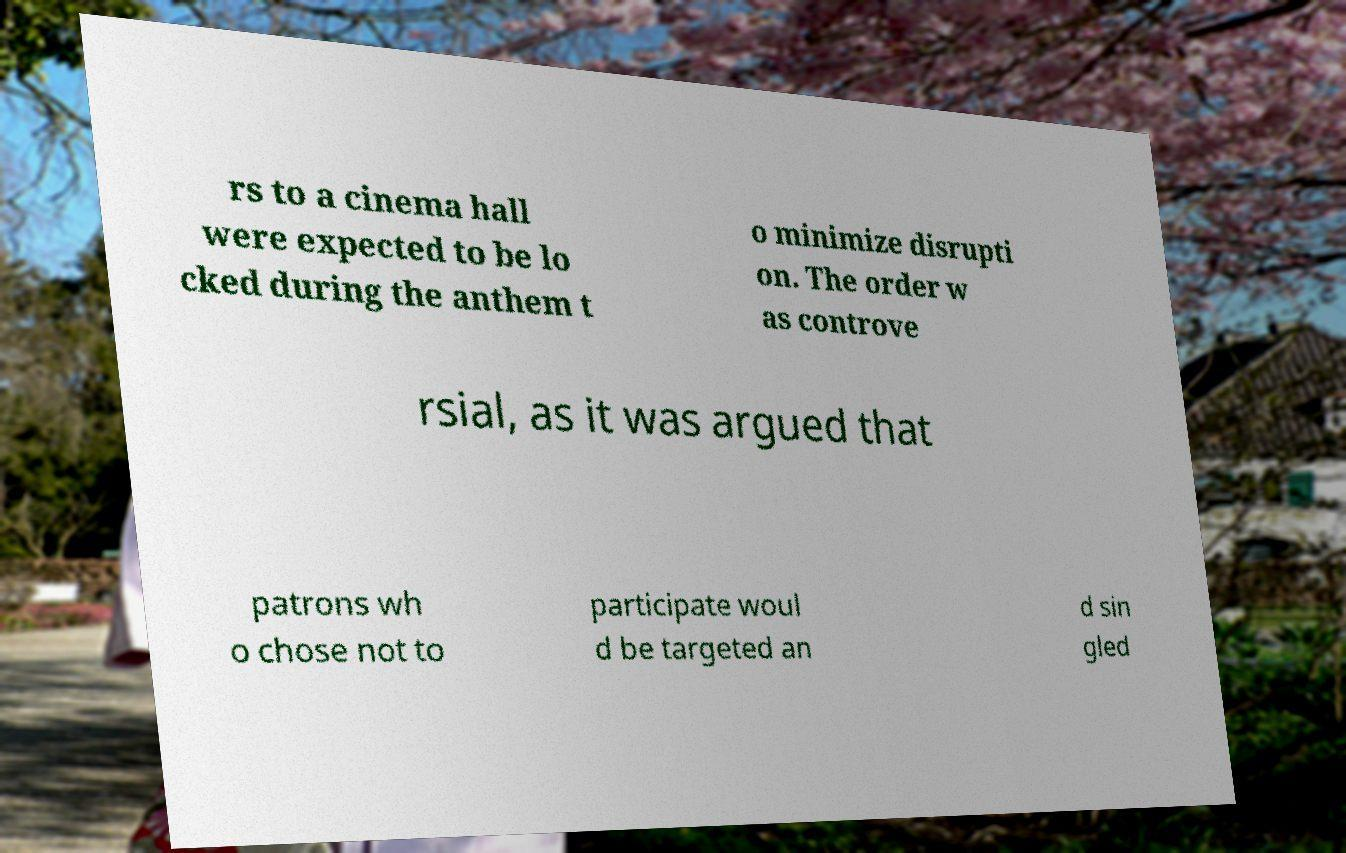For documentation purposes, I need the text within this image transcribed. Could you provide that? rs to a cinema hall were expected to be lo cked during the anthem t o minimize disrupti on. The order w as controve rsial, as it was argued that patrons wh o chose not to participate woul d be targeted an d sin gled 